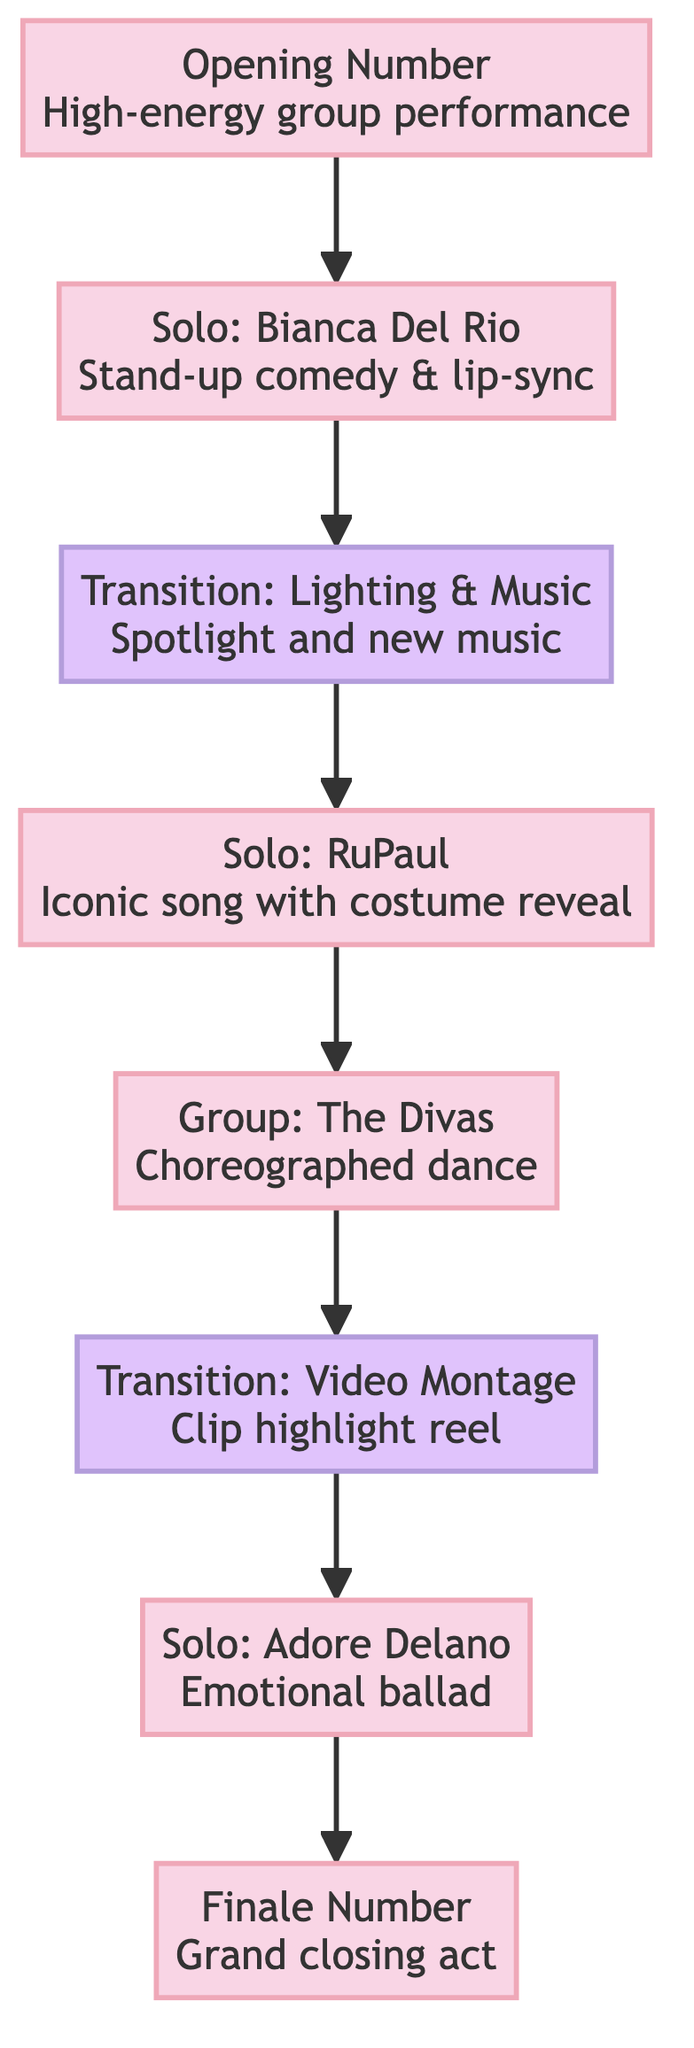What is the first act of the show? The diagram starts with the node representing the "Opening Number" which indicates it is the first act. Therefore, it clearly shows that the opening act is the first performance in the timeline.
Answer: Opening Number Which performer is featured in the second solo performance? The transition from the "Transition: Lighting & Music Change" leads directly to "Solo Performance: RuPaul," making RuPaul the performer in the second solo act.
Answer: RuPaul How many total performances are there in the diagram? Counting the nodes, we see there are seven distinct acts: one opening number, three solo performances, one group number, and one finale. Thus, there are seven performances in total.
Answer: Seven What type of performance is "Solo Performance: Adore Delano"? The description connected with the node "Solo Performance: Adore Delano" specifies it as an emotional ballad. Therefore, based on the node's content, we classify it as such.
Answer: Emotional ballad Which node appears immediately after the "Group Number: The Divas"? The diagram shows an edge from the "Group Number: The Divas" node leading to "Transition: Video Montage," indicating that this transition directly follows the group number performance.
Answer: Transition: Video Montage How many transitions are there in the performance timeline? The diagram contains two specific transitions namely "Transition: Lighting & Music Change" and "Transition: Video Montage." Hence, there are two distinct transitions present in the timeline.
Answer: Two What is performed during the finale of the show? The diagram points to the "Finale Number," which signifies that during the finale, all performers join for a grand closing act. Thus, this is what visually concludes the performance sequence in the diagram.
Answer: Grand closing act What precedes the "Solo Performance: Bianca Del Rio"? The diagram shows that "Opening Number" directly connects to "Solo Performance: Bianca Del Rio," indicating that the opening performance precedes Bianca Del Rio's solo act.
Answer: Opening Number 